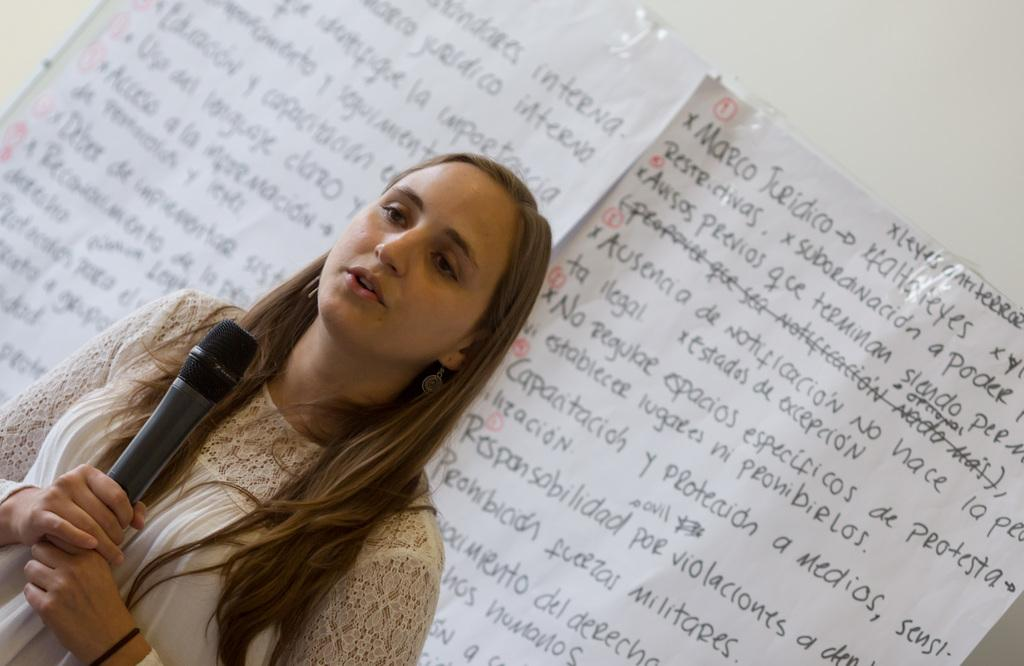Who is the main subject in the image? There is a woman in the image. What is the woman holding in the image? The woman is holding a microphone. What can be seen in the background of the image? There are papers pasted on a wall in the background of the image. Where is the sofa located in the image? There is no sofa present in the image. What is the thumb doing in the image? There is no thumb present in the image. 